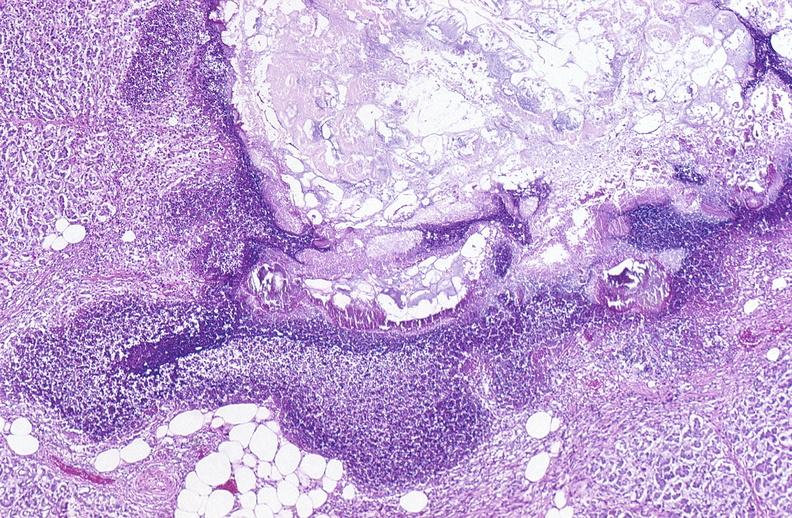does this image show pancreatic fat necrosis?
Answer the question using a single word or phrase. Yes 